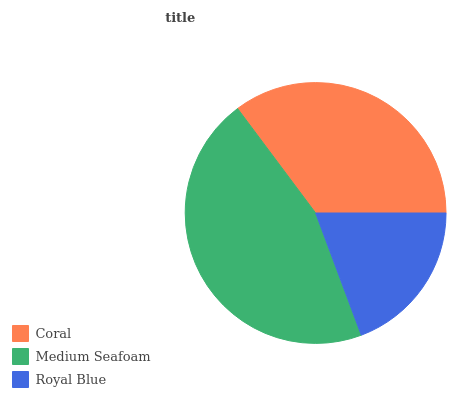Is Royal Blue the minimum?
Answer yes or no. Yes. Is Medium Seafoam the maximum?
Answer yes or no. Yes. Is Medium Seafoam the minimum?
Answer yes or no. No. Is Royal Blue the maximum?
Answer yes or no. No. Is Medium Seafoam greater than Royal Blue?
Answer yes or no. Yes. Is Royal Blue less than Medium Seafoam?
Answer yes or no. Yes. Is Royal Blue greater than Medium Seafoam?
Answer yes or no. No. Is Medium Seafoam less than Royal Blue?
Answer yes or no. No. Is Coral the high median?
Answer yes or no. Yes. Is Coral the low median?
Answer yes or no. Yes. Is Royal Blue the high median?
Answer yes or no. No. Is Royal Blue the low median?
Answer yes or no. No. 